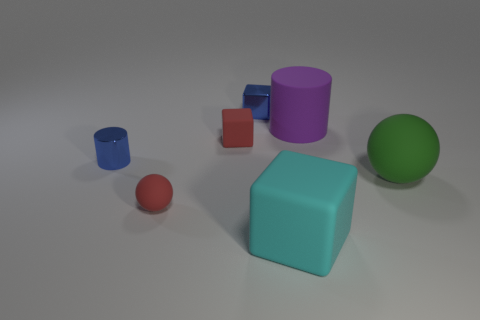Are there any other things that have the same material as the big green object?
Offer a terse response. Yes. What number of objects are both right of the cyan block and in front of the rubber cylinder?
Your answer should be compact. 1. What number of objects are either small blue things in front of the purple matte object or large things that are on the left side of the purple thing?
Your answer should be compact. 2. How many other things are the same shape as the cyan thing?
Offer a terse response. 2. There is a metal object that is in front of the big purple cylinder; is it the same color as the shiny block?
Provide a succinct answer. Yes. What number of other things are the same size as the red matte sphere?
Your answer should be very brief. 3. Is the material of the big purple cylinder the same as the tiny red cube?
Give a very brief answer. Yes. There is a cylinder to the left of the matte cube behind the large cyan matte object; what color is it?
Your answer should be very brief. Blue. What size is the blue metal thing that is the same shape as the big cyan thing?
Your answer should be compact. Small. Is the shiny cylinder the same color as the metal block?
Give a very brief answer. Yes. 